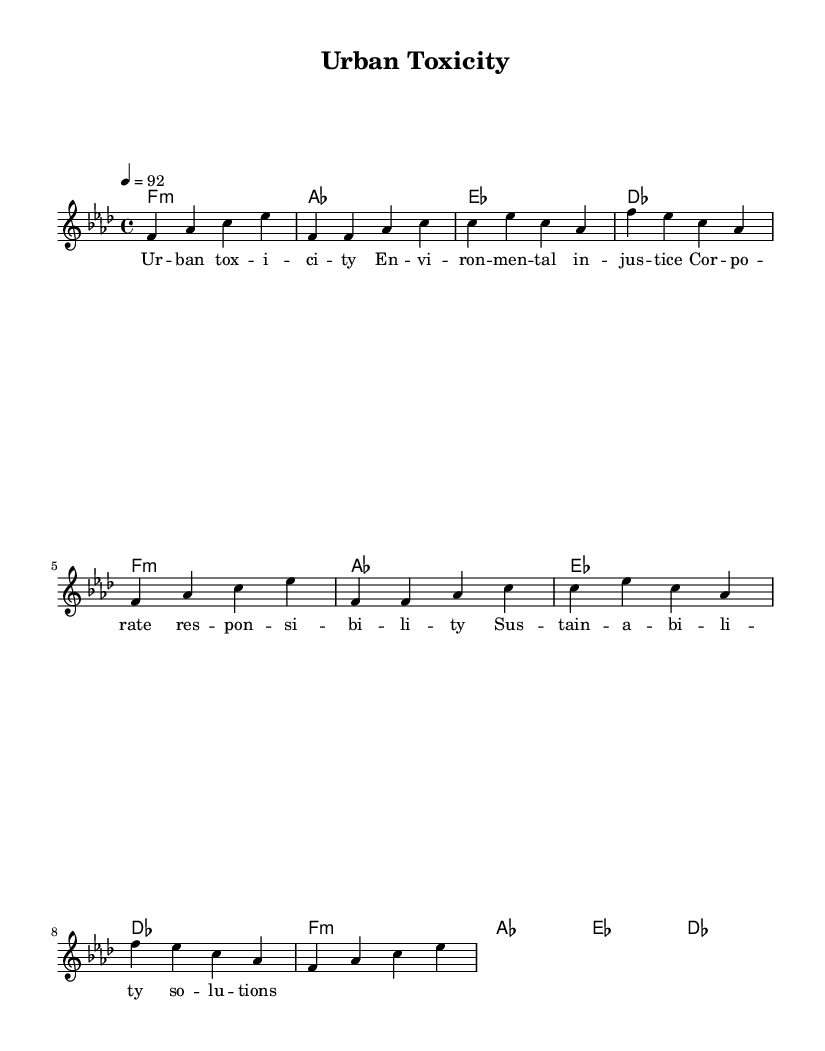What is the key signature of this music? The key signature indicated in the global section of the sheet music is F minor, which is shown as having four flats.
Answer: F minor What is the time signature of this music? The time signature is noted in the global section, showing that the piece is in 4/4 time, which means there are four beats in each measure.
Answer: 4/4 What is the tempo of this music? The tempo is indicated at the beginning of the global section as quarter note = 92 beats per minute, meaning the speed of the piece is relatively moderate.
Answer: 92 How many verses are there in the song? The sheet music shows two verses, with Verse 1 being explicitly noted and Verse 2 being repeated from the previous content.
Answer: 2 What is the primary theme of the lyrics based on the title? The title "Urban Toxicity" suggests the lyrics primarily focus on issues related to environmental injustice and corporate responsibility in urban areas, indicating a societal and ecological message.
Answer: Environmental injustice What is the structure of the song as reflected in the sheet music? The structure can be observed as having an Intro, followed by two verses and two choruses, highlighting the repetition commonly found in rap music.
Answer: Intro, Verse 1, Chorus, Verse 2, Chorus What kind of chord progression is used throughout the song? The chord progression consists of a repeating cycle of F minor chord followed by A flat major, E flat major, and D flat major, which indicates a typical foundation for a rap composition's harmonic structure.
Answer: F minor, A flat, E flat, D flat 